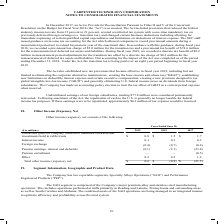According to Carpenter Technology's financial document, What was the amount of Interest income in 2019? According to the financial document, 0.1 (in millions). The relevant text states: "in rabbi trusts $ 0.8 $ 1.5 $ 1.7 Interest income 0.1 0.3 0.3 Foreign exchange (0.4) (0.7) (0.4) Pension earnings, interest and deferrals (0.1) (2.1) (23..." Also, What was the Total other income (expense), net in 2018? According to the financial document, $(0.8) (in millions). The relevant text states: "0.2 1.2 Total other income (expense), net $ 0.6 $ (0.8) $ (21.5)..." Also, In which years is total Other Income (Expense), Net calculated? The document contains multiple relevant values: 2019, 2018, 2017. From the document: "($ in millions) 2019 2018 2017 Unrealized gains on company owned life insurance contracts and investments held in rabbi trusts $ 0 ($ in millions) 201..." Additionally, In which year was Other the largest? According to the financial document, 2017. The relevant text states: "($ in millions) 2019 2018 2017 Unrealized gains on company owned life insurance contracts and investments held in rabbi trusts $ 0..." Also, can you calculate: What was the change in interest income in 2019 from 2018? Based on the calculation: 0.1-0.3, the result is -0.2 (in millions). This is based on the information: "abbi trusts $ 0.8 $ 1.5 $ 1.7 Interest income 0.1 0.3 0.3 Foreign exchange (0.4) (0.7) (0.4) Pension earnings, interest and deferrals (0.1) (2.1) (23.8) in rabbi trusts $ 0.8 $ 1.5 $ 1.7 Interest inco..." The key data points involved are: 0.1, 0.3. Also, can you calculate: What was the percentage change in interest income in 2019 from 2018? To answer this question, I need to perform calculations using the financial data. The calculation is: (0.1-0.3)/0.3, which equals -66.67 (percentage). This is based on the information: "abbi trusts $ 0.8 $ 1.5 $ 1.7 Interest income 0.1 0.3 0.3 Foreign exchange (0.4) (0.7) (0.4) Pension earnings, interest and deferrals (0.1) (2.1) (23.8) in rabbi trusts $ 0.8 $ 1.5 $ 1.7 Interest inco..." The key data points involved are: 0.1, 0.3. 